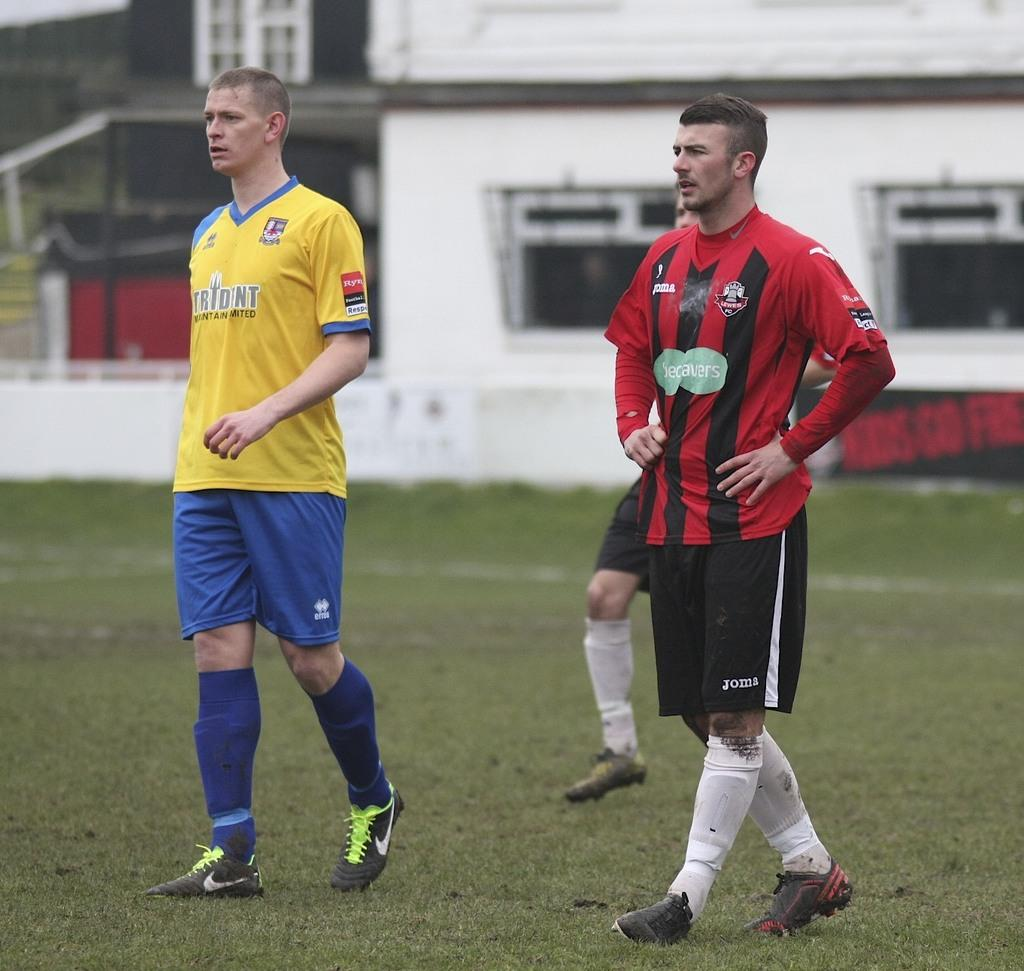<image>
Share a concise interpretation of the image provided. A football player has the word Trident on a yellow shirt. 